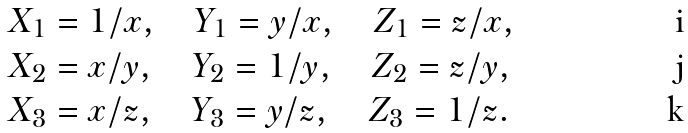<formula> <loc_0><loc_0><loc_500><loc_500>& X _ { 1 } = 1 / x , \quad Y _ { 1 } = y / x , \quad Z _ { 1 } = z / x , \\ & X _ { 2 } = x / y , \quad Y _ { 2 } = 1 / y , \quad Z _ { 2 } = z / y , \\ & X _ { 3 } = x / z , \quad Y _ { 3 } = y / z , \quad Z _ { 3 } = 1 / z .</formula> 